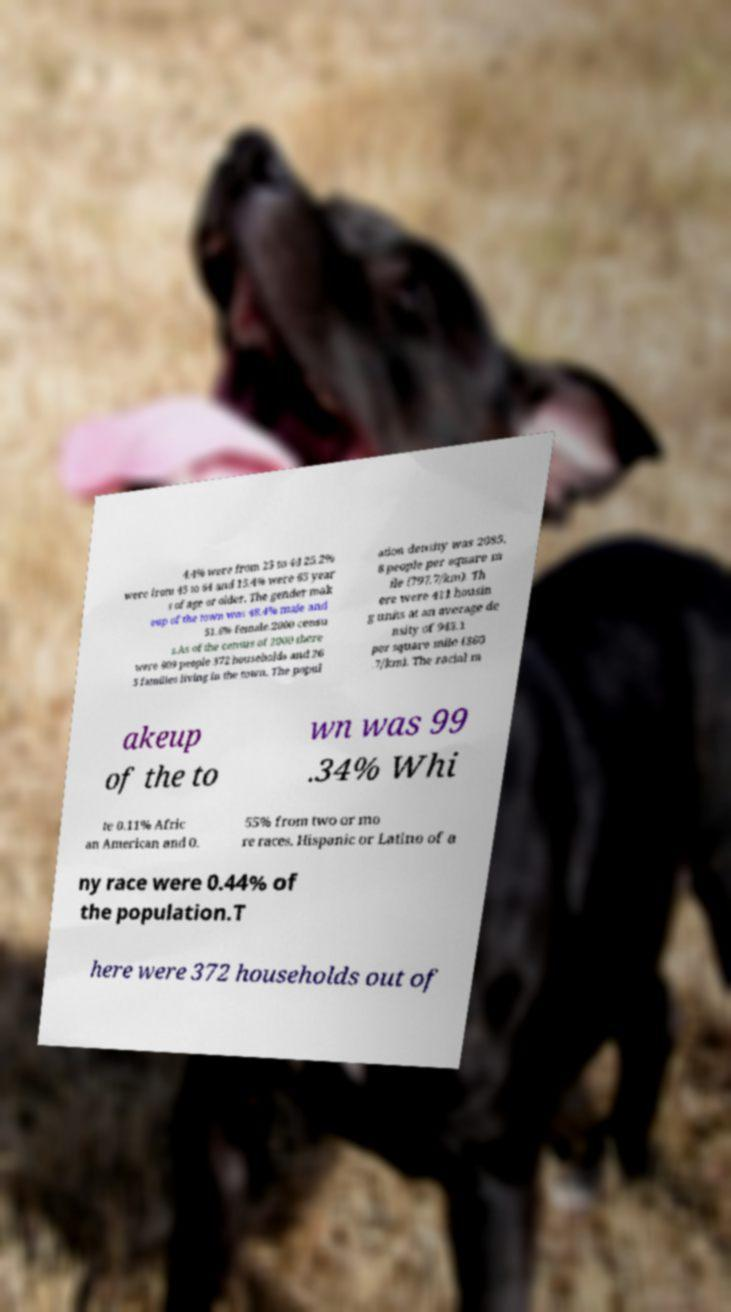Please read and relay the text visible in this image. What does it say? 4.4% were from 25 to 44 25.2% were from 45 to 64 and 15.4% were 65 year s of age or older. The gender mak eup of the town was 48.4% male and 51.6% female.2000 censu s.As of the census of 2000 there were 909 people 372 households and 26 5 families living in the town. The popul ation density was 2085. 8 people per square m ile (797.7/km). Th ere were 411 housin g units at an average de nsity of 943.1 per square mile (360 .7/km). The racial m akeup of the to wn was 99 .34% Whi te 0.11% Afric an American and 0. 55% from two or mo re races. Hispanic or Latino of a ny race were 0.44% of the population.T here were 372 households out of 